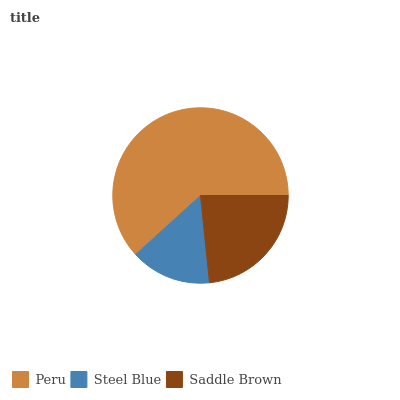Is Steel Blue the minimum?
Answer yes or no. Yes. Is Peru the maximum?
Answer yes or no. Yes. Is Saddle Brown the minimum?
Answer yes or no. No. Is Saddle Brown the maximum?
Answer yes or no. No. Is Saddle Brown greater than Steel Blue?
Answer yes or no. Yes. Is Steel Blue less than Saddle Brown?
Answer yes or no. Yes. Is Steel Blue greater than Saddle Brown?
Answer yes or no. No. Is Saddle Brown less than Steel Blue?
Answer yes or no. No. Is Saddle Brown the high median?
Answer yes or no. Yes. Is Saddle Brown the low median?
Answer yes or no. Yes. Is Steel Blue the high median?
Answer yes or no. No. Is Peru the low median?
Answer yes or no. No. 